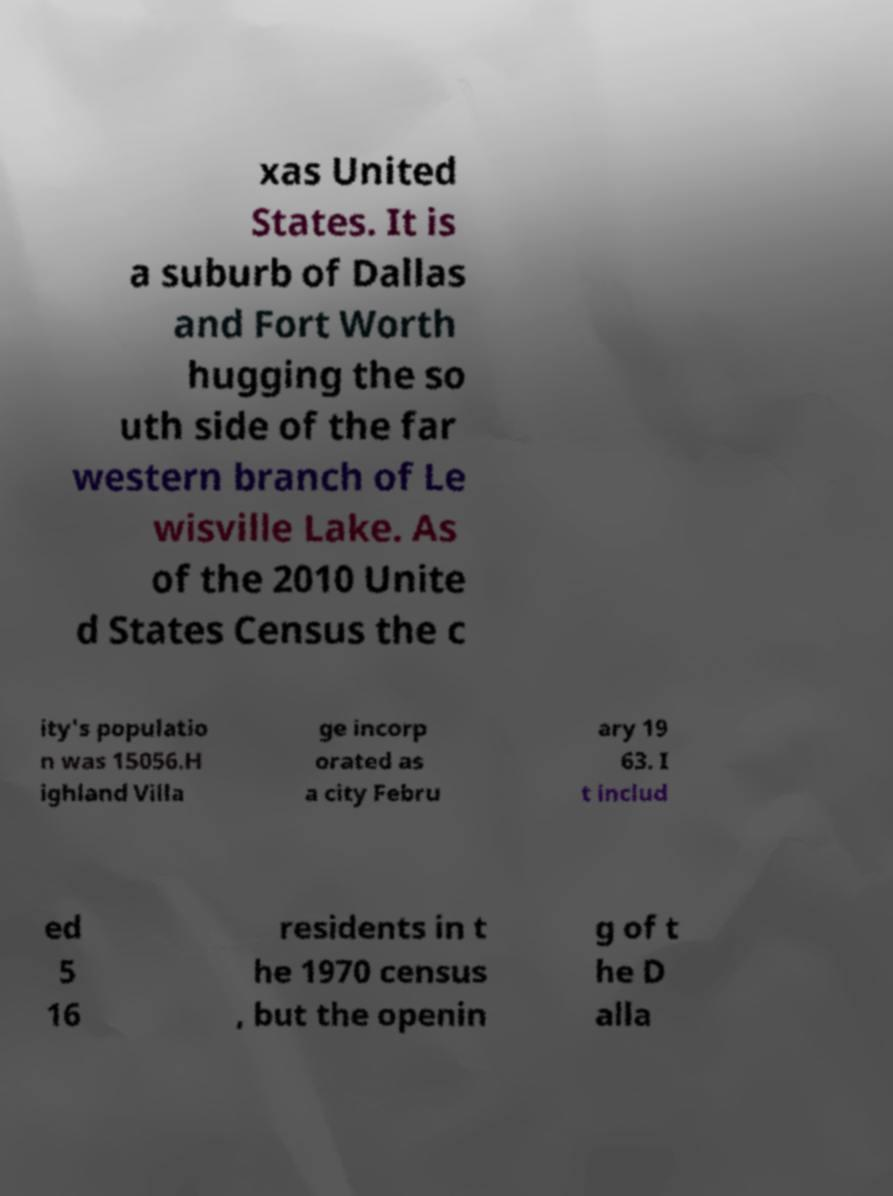Could you assist in decoding the text presented in this image and type it out clearly? xas United States. It is a suburb of Dallas and Fort Worth hugging the so uth side of the far western branch of Le wisville Lake. As of the 2010 Unite d States Census the c ity's populatio n was 15056.H ighland Villa ge incorp orated as a city Febru ary 19 63. I t includ ed 5 16 residents in t he 1970 census , but the openin g of t he D alla 